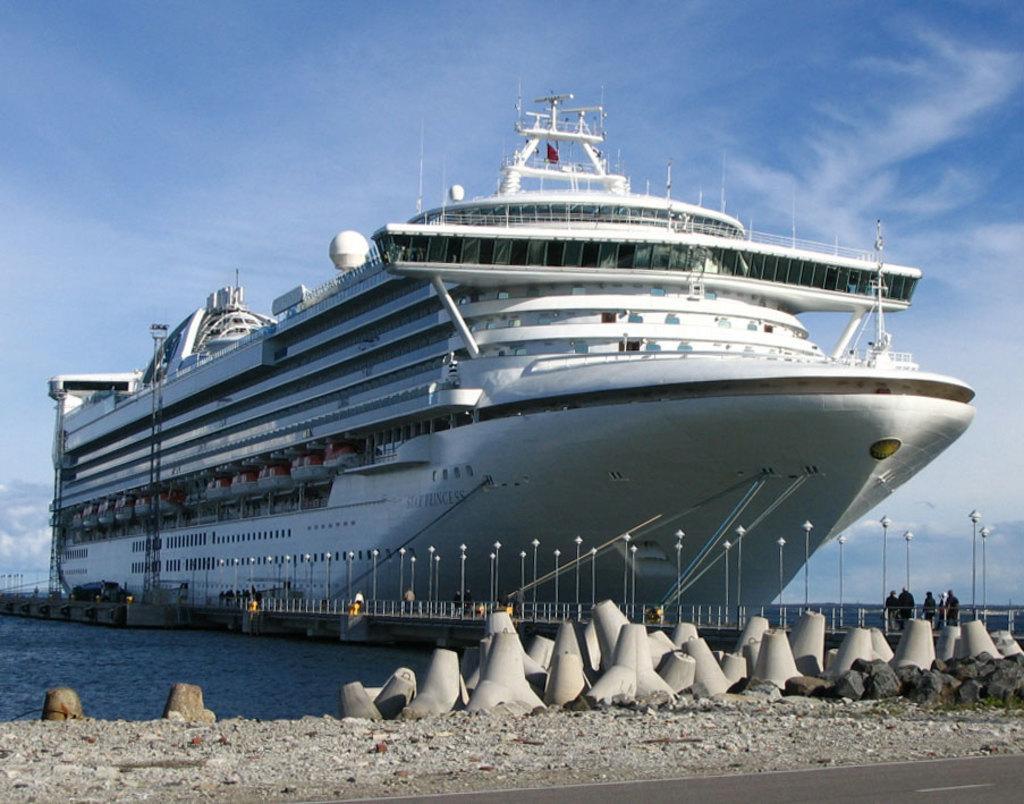In one or two sentences, can you explain what this image depicts? In this picture we can see big ship on the water, beside that we can see a bridge. On the bridge we can see fencing, street lights, poles, car and peoples. On the bottom we can see stones near to the road. At the top we can see sky and clouds. 